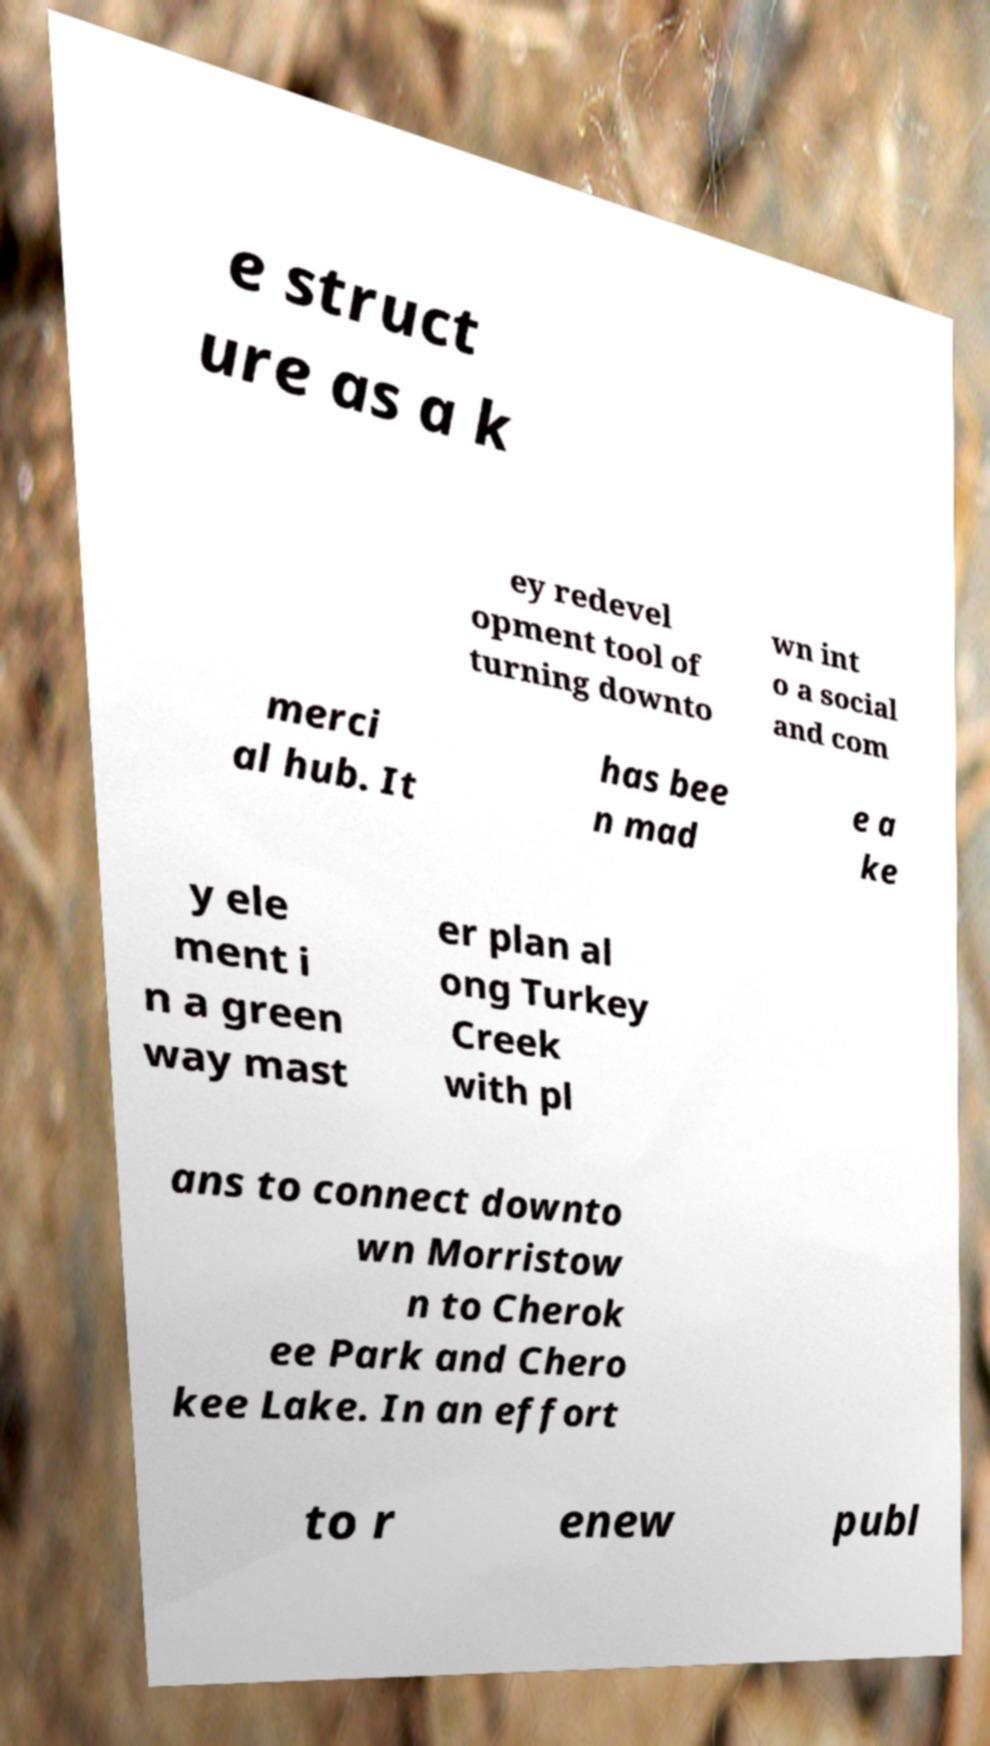Can you accurately transcribe the text from the provided image for me? e struct ure as a k ey redevel opment tool of turning downto wn int o a social and com merci al hub. It has bee n mad e a ke y ele ment i n a green way mast er plan al ong Turkey Creek with pl ans to connect downto wn Morristow n to Cherok ee Park and Chero kee Lake. In an effort to r enew publ 